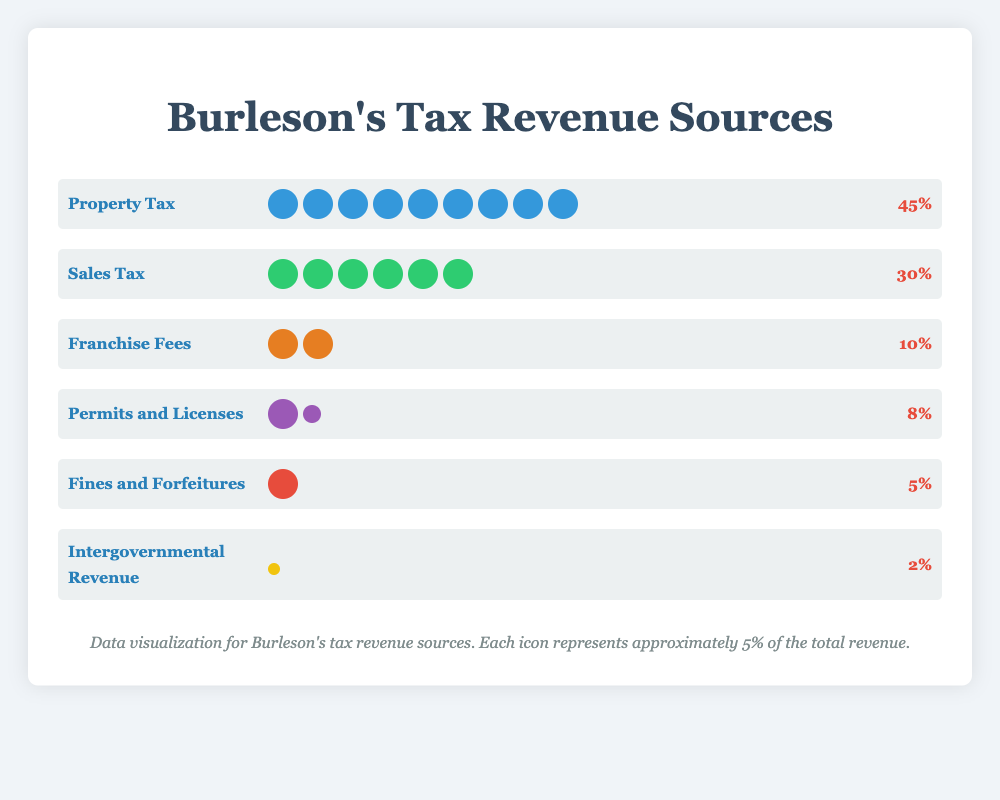Which source contributes the most to Burleson's tax revenue? By looking at the figure, we see that Property Tax has 9 icons, translating to 45%, which is the highest percentage among the sources.
Answer: Property Tax What percentage of Burleson's tax revenue comes from Sales Tax and Fines and Forfeitures combined? Sales Tax contributes 30% and Fines and Forfeitures contribute 5%. Adding these together: 30% + 5% = 35%.
Answer: 35% How much more does Property Tax contribute compared to Franchise Fees? Property Tax contributes 45%, and Franchise Fees contribute 10%. The difference is 45% - 10% = 35%.
Answer: 35% Which two sources have the same number of icons? By observing the icons, Franchise Fees and Permits and Licenses both have 2 icons each.
Answer: Franchise Fees and Permits and Licenses What is the total percentage contribution of the sources with only one icon? Intergovernmental Revenue and Fines and Forfeitures each have 1 icon. The contributions are 2% and 5%, respectively. Adding these gives 2% + 5% = 7%.
Answer: 7% Which source has the least contribution to Burleson's tax revenue? Intergovernmental Revenue has the smallest icon and percentage, which is 2%.
Answer: Intergovernmental Revenue What is the difference in percentage between Sales Tax and Permits and Licenses? Sales Tax's contribution is 30%, and Permits and Licenses contribute 8%. The difference is 30% - 8% = 22%.
Answer: 22% How many sources contribute more than 10% to the tax revenue? Only Property Tax (45%) and Sales Tax (30%) contribute more than 10%.
Answer: 2 Is the combined contribution of Franchise Fees and Permits and Licenses greater than Sales Tax? Franchise Fees contribute 10% and Permits and Licenses contribute 8%. Adding these gives 10% + 8% = 18%, which is less than Sales Tax's 30%.
Answer: No How many total icons are there in the chart? Counting all icons: Property Tax (9) + Sales Tax (6) + Franchise Fees (2) + Permits and Licenses (2) + Fines and Forfeitures (1) + Intergovernmental Revenue (1) = 21.
Answer: 21 